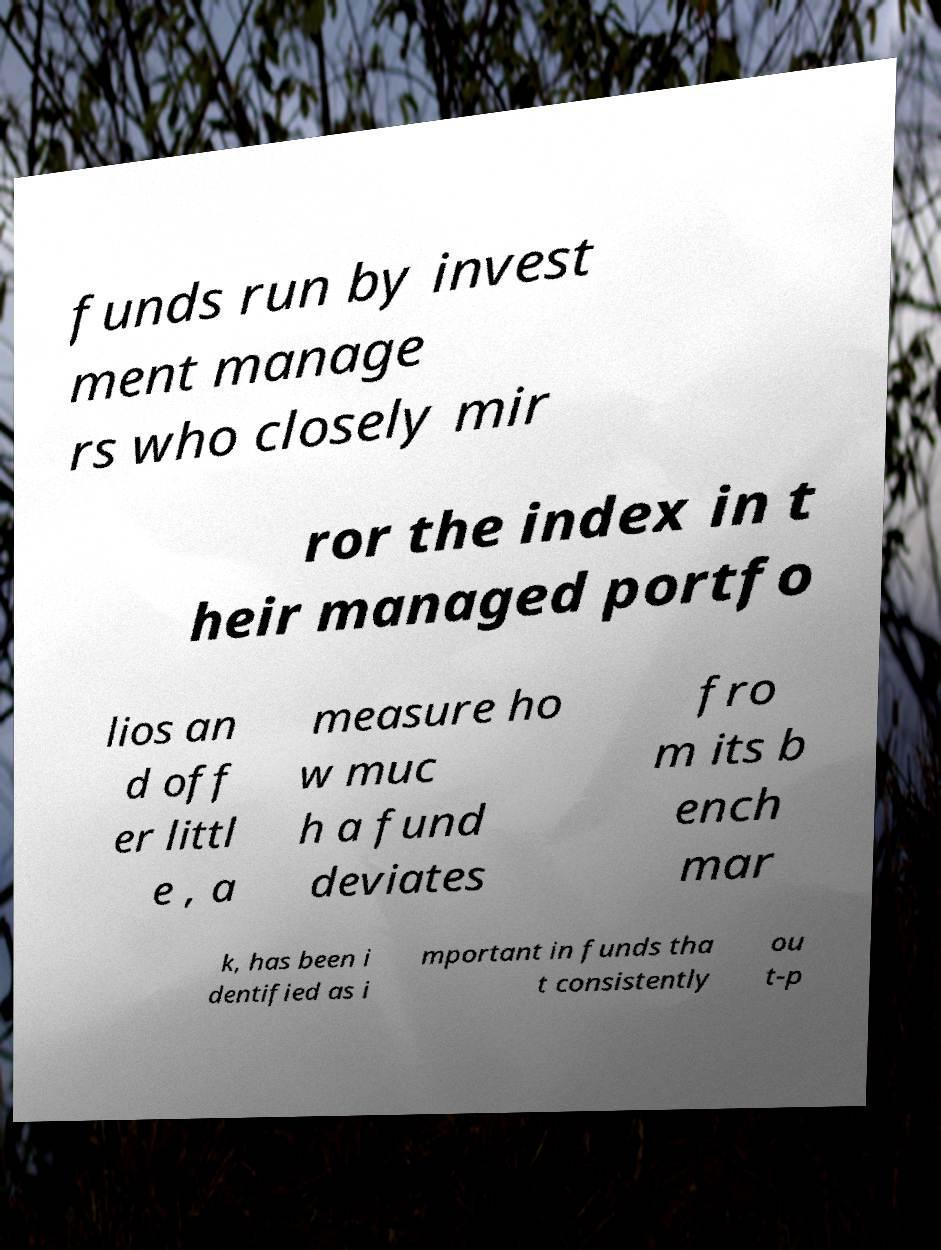There's text embedded in this image that I need extracted. Can you transcribe it verbatim? funds run by invest ment manage rs who closely mir ror the index in t heir managed portfo lios an d off er littl e , a measure ho w muc h a fund deviates fro m its b ench mar k, has been i dentified as i mportant in funds tha t consistently ou t-p 